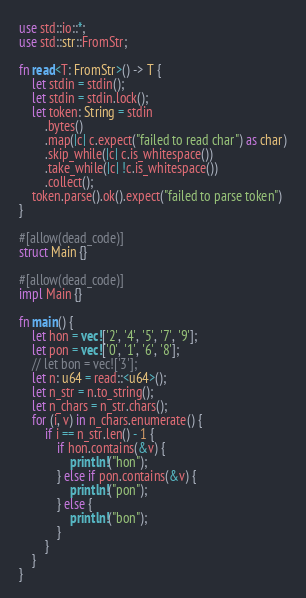Convert code to text. <code><loc_0><loc_0><loc_500><loc_500><_Rust_>use std::io::*;
use std::str::FromStr;

fn read<T: FromStr>() -> T {
    let stdin = stdin();
    let stdin = stdin.lock();
    let token: String = stdin
        .bytes()
        .map(|c| c.expect("failed to read char") as char)
        .skip_while(|c| c.is_whitespace())
        .take_while(|c| !c.is_whitespace())
        .collect();
    token.parse().ok().expect("failed to parse token")
}

#[allow(dead_code)]
struct Main {}

#[allow(dead_code)]
impl Main {}

fn main() {
    let hon = vec!['2', '4', '5', '7', '9'];
    let pon = vec!['0', '1', '6', '8'];
    // let bon = vec!['3'];
    let n: u64 = read::<u64>();
    let n_str = n.to_string();
    let n_chars = n_str.chars();
    for (i, v) in n_chars.enumerate() {
        if i == n_str.len() - 1 {
            if hon.contains(&v) {
                println!("hon");
            } else if pon.contains(&v) {
                println!("pon");
            } else {
                println!("bon");
            }
        }
    }
}
</code> 